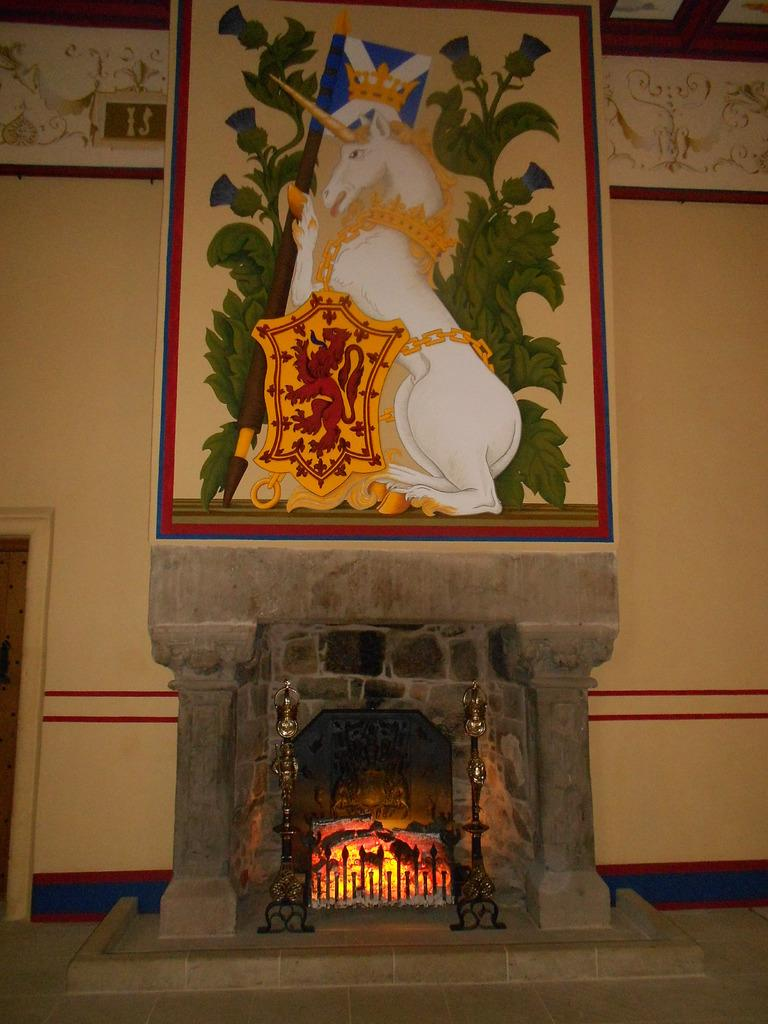What type of surface is visible in the image? The image contains a floor. What architectural feature can be seen in the image? There is a fireplace in the image. Can you describe an object on the wall in the background of the image? There is a photo frame on the wall in the background of the image. What is the condition of the point in the image? There is no point present in the image, so it is not possible to determine its condition. 